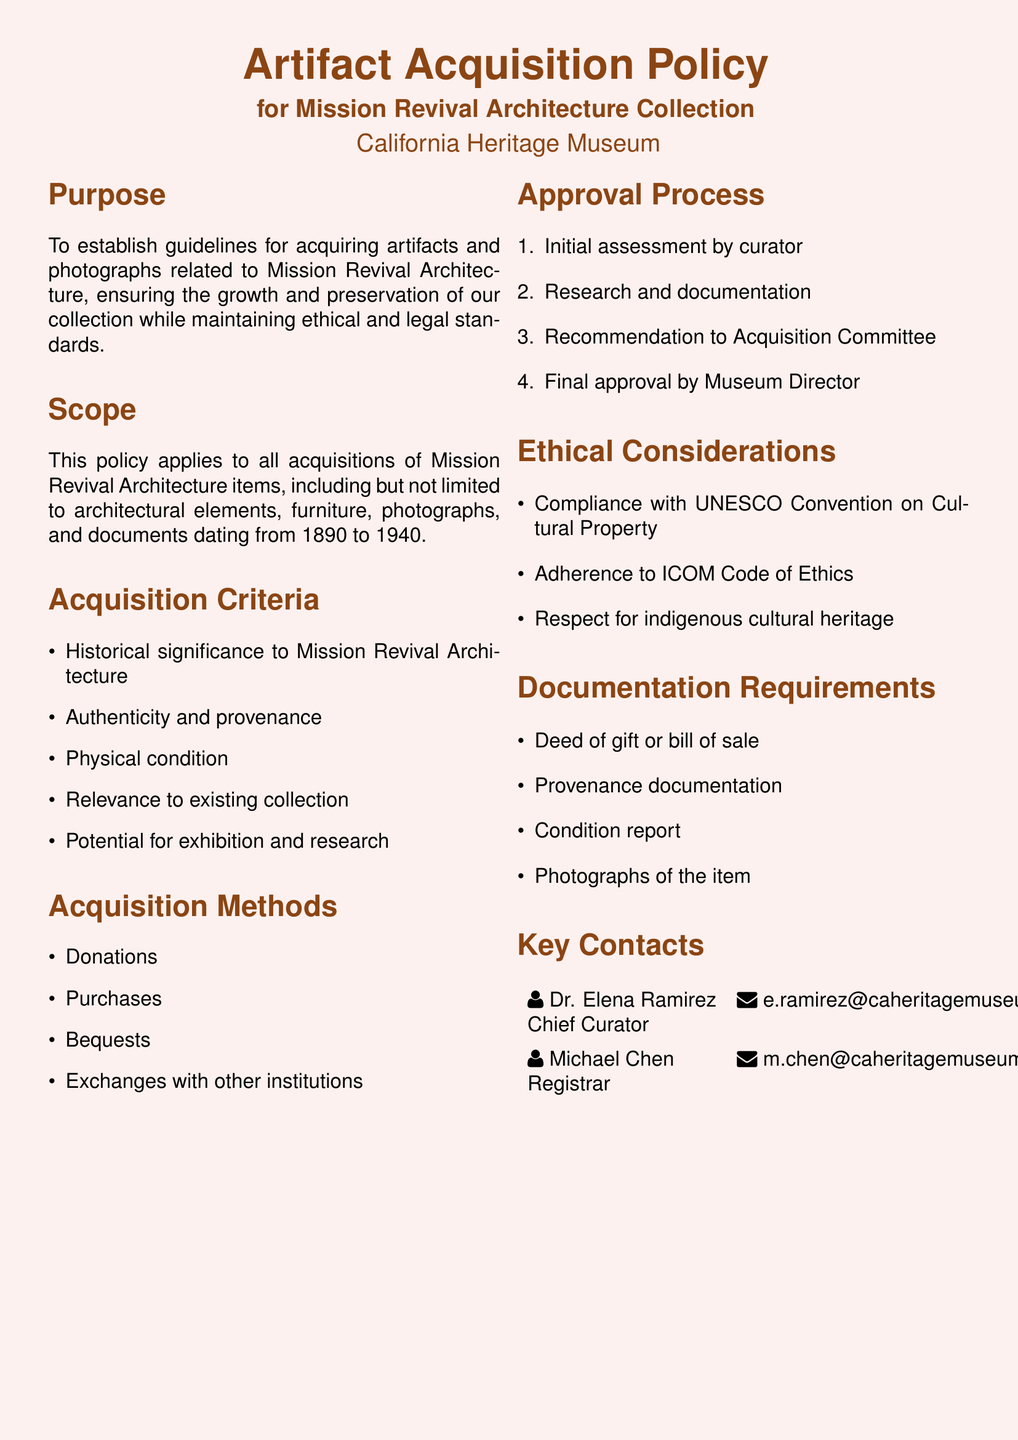What is the purpose of the policy? The purpose is to establish guidelines for acquiring artifacts and photographs related to Mission Revival Architecture.
Answer: To establish guidelines What is the date range for the items considered for acquisition? The date range specified in the document for artifacts and photographs is from 1890 to 1940.
Answer: 1890 to 1940 Who is the Chief Curator? The document lists Dr. Elena Ramirez as the Chief Curator.
Answer: Dr. Elena Ramirez What is one method of acquisition mentioned? The document states that one acquisition method is donations.
Answer: Donations What is required for documentation when acquiring an item? The policy requires a deed of gift or bill of sale as part of the documentation.
Answer: Deed of gift or bill of sale How many steps are in the approval process? The document outlines a four-step approval process for acquisitions.
Answer: Four What ethical consideration is mentioned in relation to indigenous cultural heritage? The policy emphasizes respect for indigenous cultural heritage as an ethical consideration.
Answer: Respect for indigenous cultural heritage What organization’s code of ethics does the policy adhere to? The policy adheres to the ICOM Code of Ethics.
Answer: ICOM Code of Ethics Which committee makes the recommendation after the curator's assessment? The Acquisition Committee is responsible for receiving recommendations after the initial curator assessment.
Answer: Acquisition Committee 